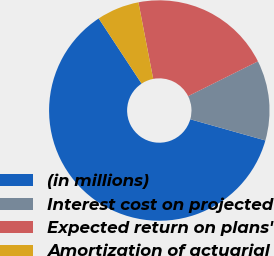Convert chart to OTSL. <chart><loc_0><loc_0><loc_500><loc_500><pie_chart><fcel>(in millions)<fcel>Interest cost on projected<fcel>Expected return on plans'<fcel>Amortization of actuarial<nl><fcel>61.35%<fcel>11.74%<fcel>20.67%<fcel>6.23%<nl></chart> 